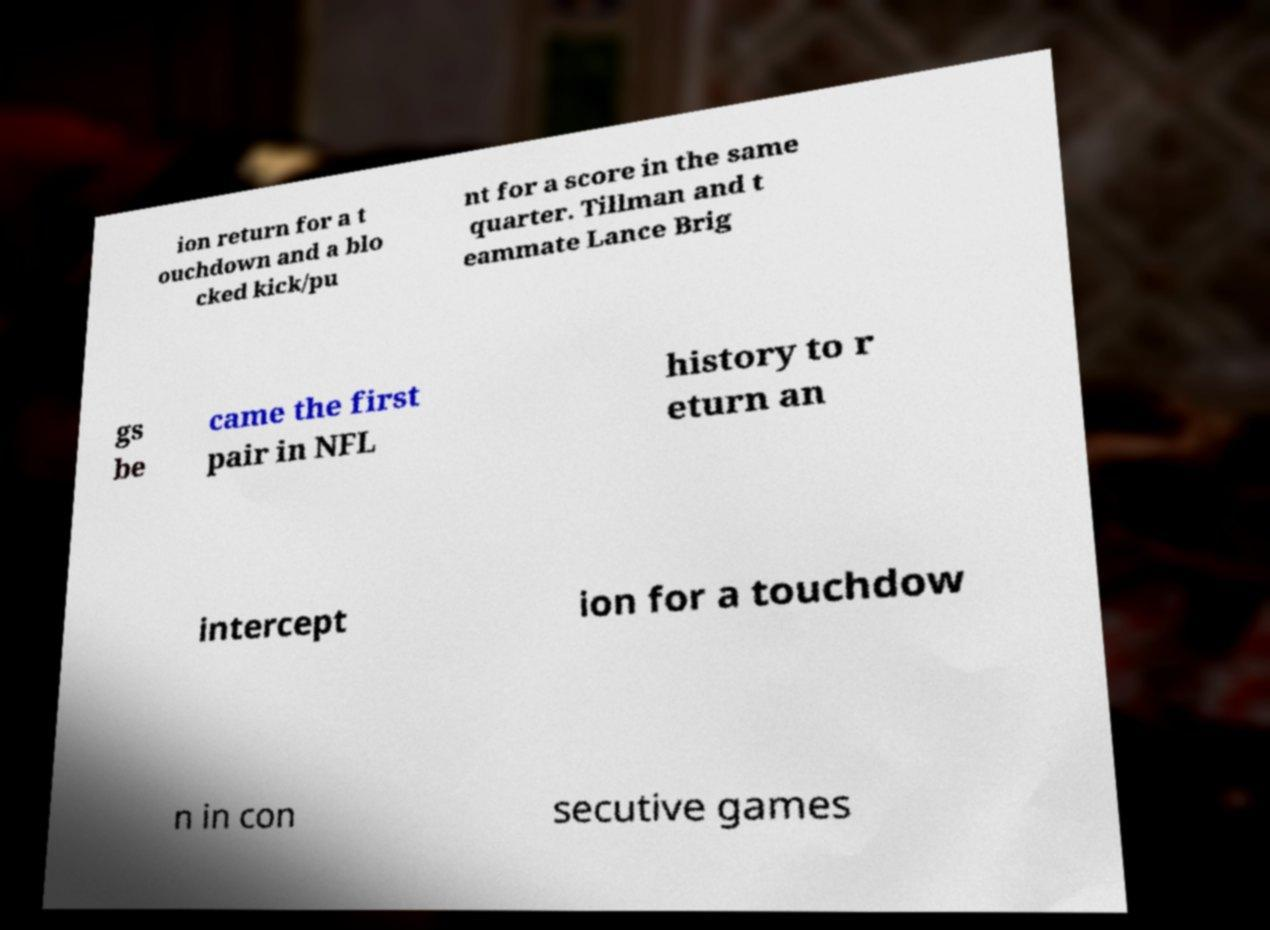Can you accurately transcribe the text from the provided image for me? ion return for a t ouchdown and a blo cked kick/pu nt for a score in the same quarter. Tillman and t eammate Lance Brig gs be came the first pair in NFL history to r eturn an intercept ion for a touchdow n in con secutive games 